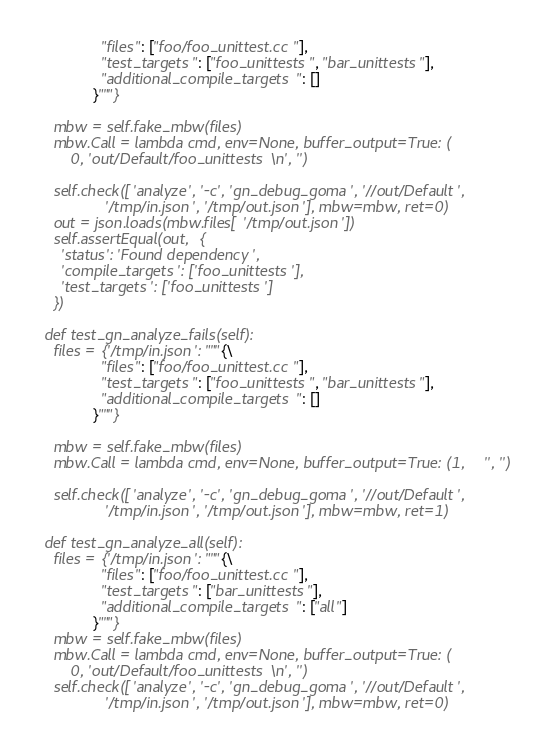<code> <loc_0><loc_0><loc_500><loc_500><_Python_>               "files": ["foo/foo_unittest.cc"],
               "test_targets": ["foo_unittests", "bar_unittests"],
               "additional_compile_targets": []
             }"""}

    mbw = self.fake_mbw(files)
    mbw.Call = lambda cmd, env=None, buffer_output=True: (
        0, 'out/Default/foo_unittests\n', '')

    self.check(['analyze', '-c', 'gn_debug_goma', '//out/Default',
                '/tmp/in.json', '/tmp/out.json'], mbw=mbw, ret=0)
    out = json.loads(mbw.files['/tmp/out.json'])
    self.assertEqual(out, {
      'status': 'Found dependency',
      'compile_targets': ['foo_unittests'],
      'test_targets': ['foo_unittests']
    })

  def test_gn_analyze_fails(self):
    files = {'/tmp/in.json': """{\
               "files": ["foo/foo_unittest.cc"],
               "test_targets": ["foo_unittests", "bar_unittests"],
               "additional_compile_targets": []
             }"""}

    mbw = self.fake_mbw(files)
    mbw.Call = lambda cmd, env=None, buffer_output=True: (1, '', '')

    self.check(['analyze', '-c', 'gn_debug_goma', '//out/Default',
                '/tmp/in.json', '/tmp/out.json'], mbw=mbw, ret=1)

  def test_gn_analyze_all(self):
    files = {'/tmp/in.json': """{\
               "files": ["foo/foo_unittest.cc"],
               "test_targets": ["bar_unittests"],
               "additional_compile_targets": ["all"]
             }"""}
    mbw = self.fake_mbw(files)
    mbw.Call = lambda cmd, env=None, buffer_output=True: (
        0, 'out/Default/foo_unittests\n', '')
    self.check(['analyze', '-c', 'gn_debug_goma', '//out/Default',
                '/tmp/in.json', '/tmp/out.json'], mbw=mbw, ret=0)</code> 